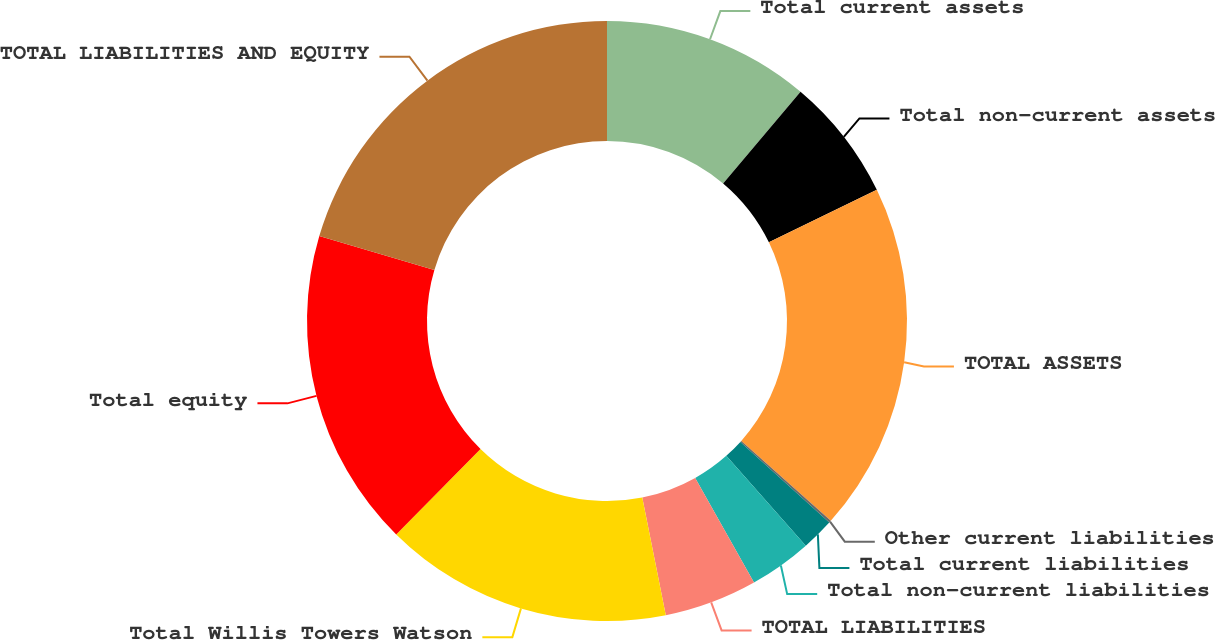<chart> <loc_0><loc_0><loc_500><loc_500><pie_chart><fcel>Total current assets<fcel>Total non-current assets<fcel>TOTAL ASSETS<fcel>Other current liabilities<fcel>Total current liabilities<fcel>Total non-current liabilities<fcel>TOTAL LIABILITIES<fcel>Total Willis Towers Watson<fcel>Total equity<fcel>TOTAL LIABILITIES AND EQUITY<nl><fcel>11.16%<fcel>6.64%<fcel>18.8%<fcel>0.12%<fcel>1.75%<fcel>3.38%<fcel>5.01%<fcel>15.54%<fcel>17.17%<fcel>20.43%<nl></chart> 